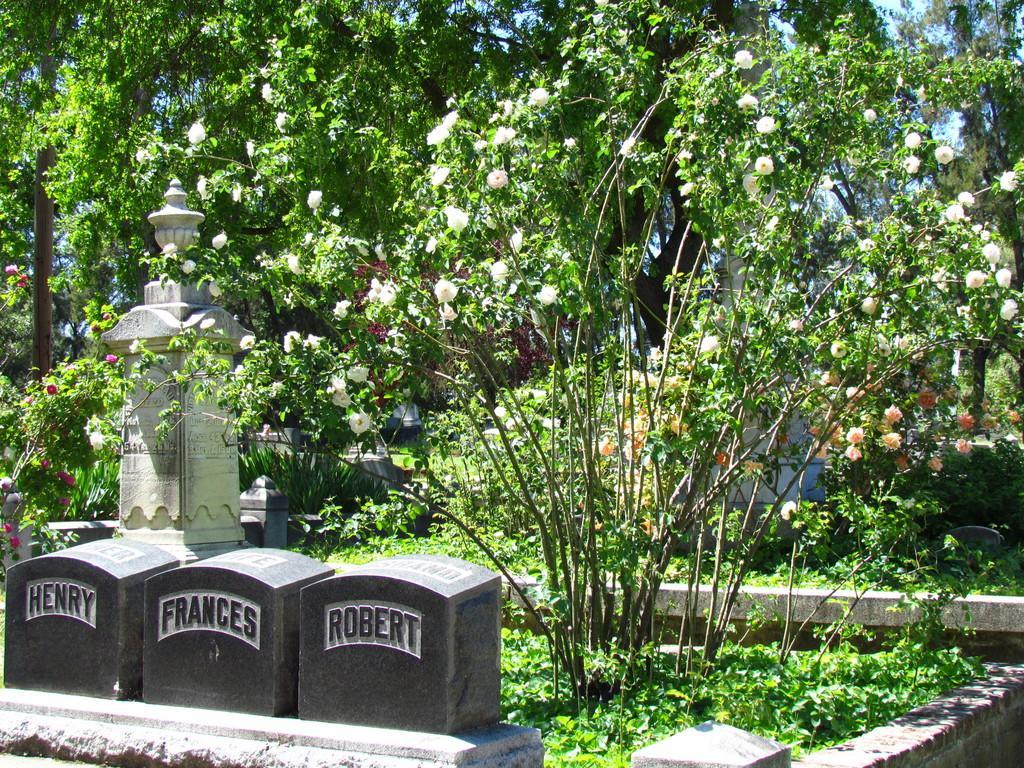How would you summarize this image in a sentence or two? At the bottom of the picture, we see headstones. Behind that, we see a pillar. There are many trees in the background. Behind that, we see a white building. 